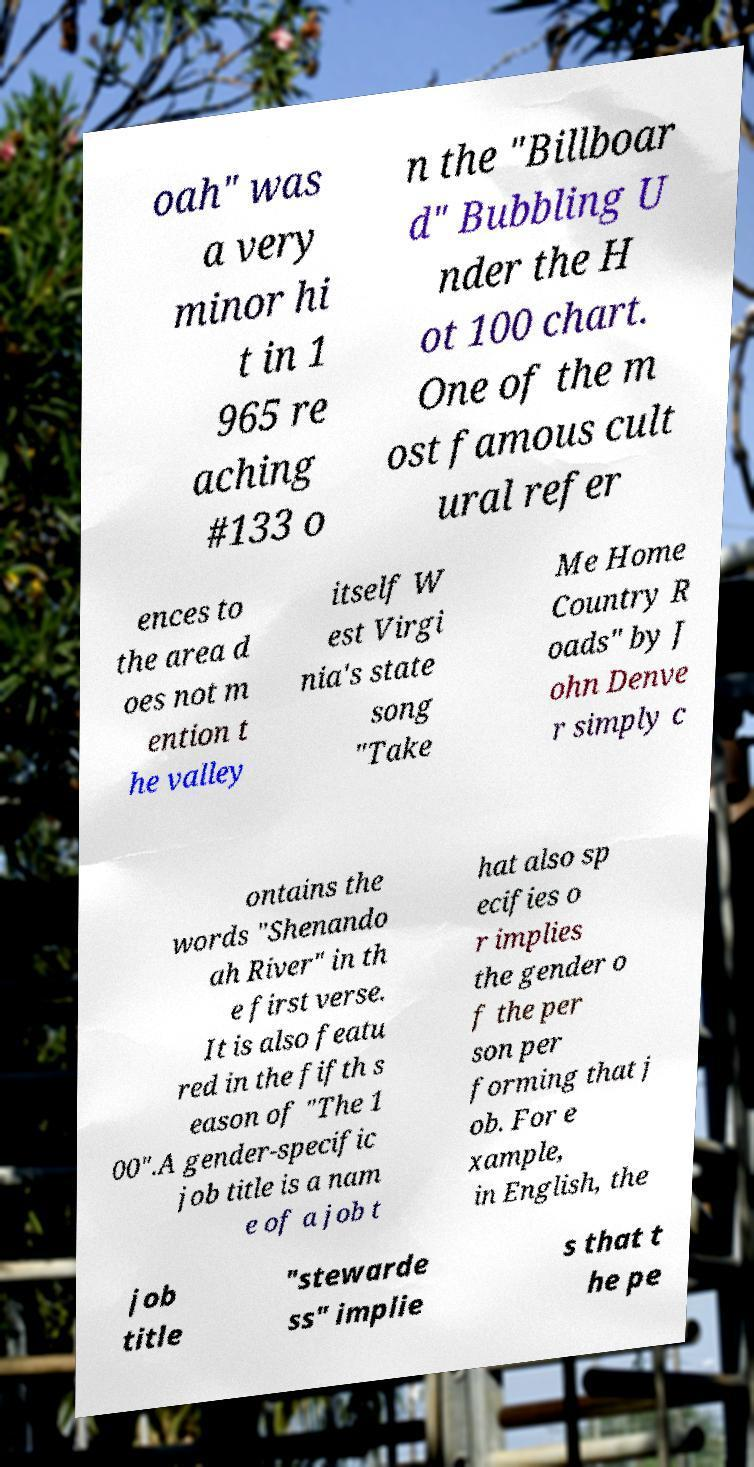Please read and relay the text visible in this image. What does it say? oah" was a very minor hi t in 1 965 re aching #133 o n the "Billboar d" Bubbling U nder the H ot 100 chart. One of the m ost famous cult ural refer ences to the area d oes not m ention t he valley itself W est Virgi nia's state song "Take Me Home Country R oads" by J ohn Denve r simply c ontains the words "Shenando ah River" in th e first verse. It is also featu red in the fifth s eason of "The 1 00".A gender-specific job title is a nam e of a job t hat also sp ecifies o r implies the gender o f the per son per forming that j ob. For e xample, in English, the job title "stewarde ss" implie s that t he pe 